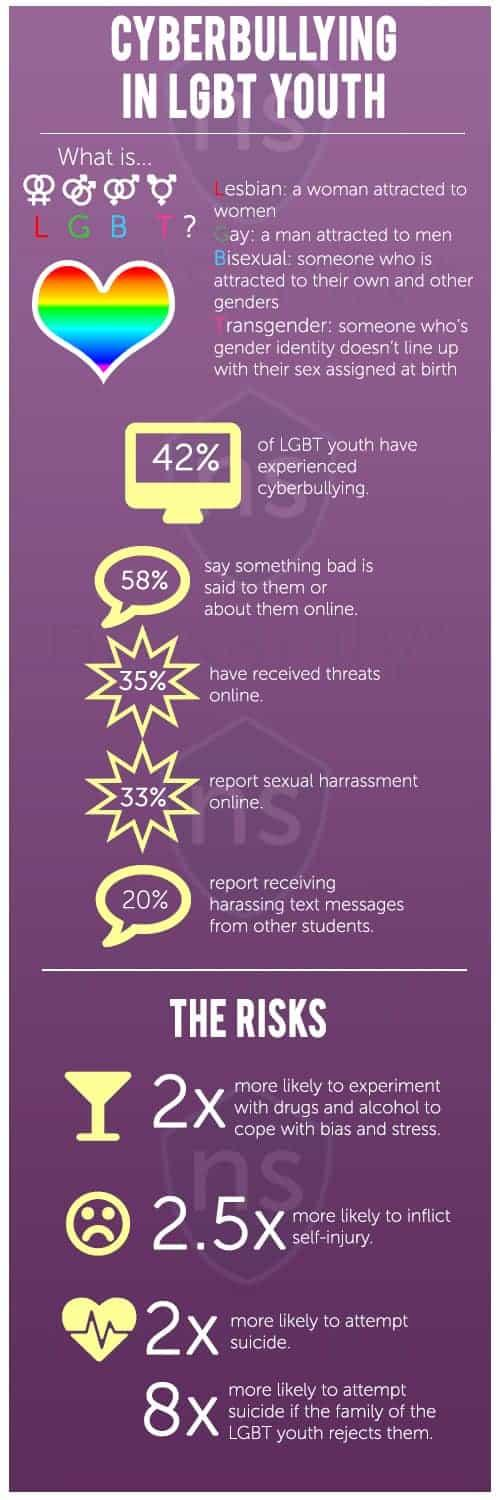Point out several critical features in this image. The abbreviation "T" in LGBT stands for "transgender. The term "L" in LGBT refers to lesbian. In the LGBT community, 'G' refers to 'Gay,' as in a person who is attracted to individuals of the same sex. Nearly one-third of LGBT youth reported experiencing sexual harassment online, according to a recent study. The abbreviation "B" in LGBT stands for "bisexual. 